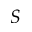<formula> <loc_0><loc_0><loc_500><loc_500>S</formula> 